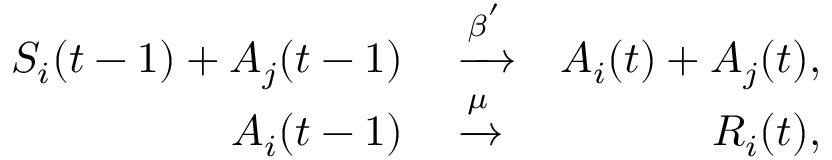<formula> <loc_0><loc_0><loc_500><loc_500>\begin{array} { r l r } { S _ { i } ( t - 1 ) + A _ { j } ( t - 1 ) } & \xrightarrow { \beta ^ { ^ { \prime } } } } & { A _ { i } ( t ) + A _ { j } ( t ) , } \\ { A _ { i } ( t - 1 ) } & \xrightarrow { \mu } } & { R _ { i } ( t ) , } \end{array}</formula> 